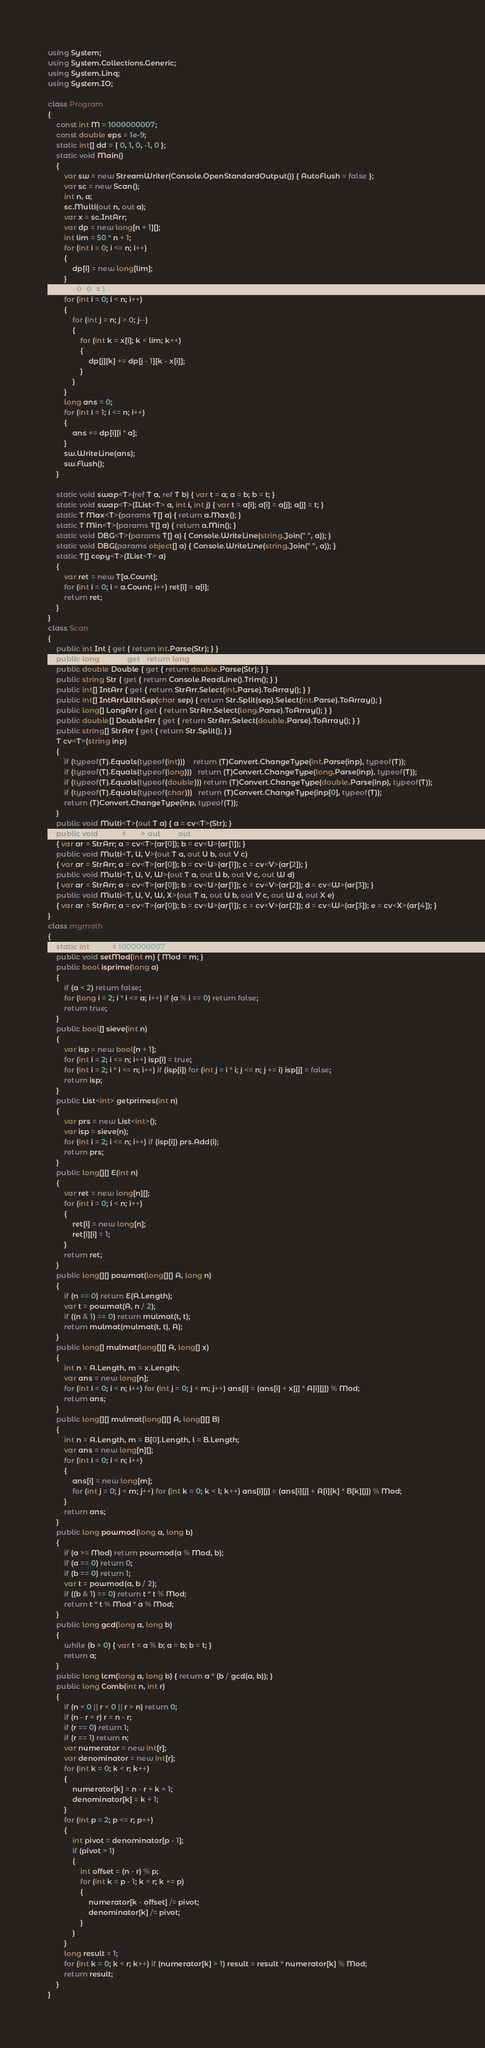Convert code to text. <code><loc_0><loc_0><loc_500><loc_500><_C#_>using System;
using System.Collections.Generic;
using System.Linq;
using System.IO;

class Program
{
    const int M = 1000000007;
    const double eps = 1e-9;
    static int[] dd = { 0, 1, 0, -1, 0 };
    static void Main()
    {
        var sw = new StreamWriter(Console.OpenStandardOutput()) { AutoFlush = false };
        var sc = new Scan();
        int n, a;
        sc.Multi(out n, out a);
        var x = sc.IntArr;
        var dp = new long[n + 1][];
        int lim = 50 * n + 1;
        for (int i = 0; i <= n; i++)
        {
            dp[i] = new long[lim];
        }
        dp[0][0] = 1;
        for (int i = 0; i < n; i++)
        {
            for (int j = n; j > 0; j--)
            {
                for (int k = x[i]; k < lim; k++)
                {
                    dp[j][k] += dp[j - 1][k - x[i]];
                }
            }
        }
        long ans = 0;
        for (int i = 1; i <= n; i++)
        {
            ans += dp[i][i * a];
        }
        sw.WriteLine(ans);
        sw.Flush();
    }

    static void swap<T>(ref T a, ref T b) { var t = a; a = b; b = t; }
    static void swap<T>(IList<T> a, int i, int j) { var t = a[i]; a[i] = a[j]; a[j] = t; }
    static T Max<T>(params T[] a) { return a.Max(); }
    static T Min<T>(params T[] a) { return a.Min(); }
    static void DBG<T>(params T[] a) { Console.WriteLine(string.Join(" ", a)); }
    static void DBG(params object[] a) { Console.WriteLine(string.Join(" ", a)); }
    static T[] copy<T>(IList<T> a)
    {
        var ret = new T[a.Count];
        for (int i = 0; i < a.Count; i++) ret[i] = a[i];
        return ret;
    }
}
class Scan
{
    public int Int { get { return int.Parse(Str); } }
    public long Long { get { return long.Parse(Str); } }
    public double Double { get { return double.Parse(Str); } }
    public string Str { get { return Console.ReadLine().Trim(); } }
    public int[] IntArr { get { return StrArr.Select(int.Parse).ToArray(); } }
    public int[] IntArrWithSep(char sep) { return Str.Split(sep).Select(int.Parse).ToArray(); }
    public long[] LongArr { get { return StrArr.Select(long.Parse).ToArray(); } }
    public double[] DoubleArr { get { return StrArr.Select(double.Parse).ToArray(); } }
    public string[] StrArr { get { return Str.Split(); } }
    T cv<T>(string inp)
    {
        if (typeof(T).Equals(typeof(int)))    return (T)Convert.ChangeType(int.Parse(inp), typeof(T));
        if (typeof(T).Equals(typeof(long)))   return (T)Convert.ChangeType(long.Parse(inp), typeof(T));
        if (typeof(T).Equals(typeof(double))) return (T)Convert.ChangeType(double.Parse(inp), typeof(T));
        if (typeof(T).Equals(typeof(char)))   return (T)Convert.ChangeType(inp[0], typeof(T));
        return (T)Convert.ChangeType(inp, typeof(T));
    }
    public void Multi<T>(out T a) { a = cv<T>(Str); }
    public void Multi<T, U>(out T a, out U b)
    { var ar = StrArr; a = cv<T>(ar[0]); b = cv<U>(ar[1]); }
    public void Multi<T, U, V>(out T a, out U b, out V c)
    { var ar = StrArr; a = cv<T>(ar[0]); b = cv<U>(ar[1]); c = cv<V>(ar[2]); }
    public void Multi<T, U, V, W>(out T a, out U b, out V c, out W d)
    { var ar = StrArr; a = cv<T>(ar[0]); b = cv<U>(ar[1]); c = cv<V>(ar[2]); d = cv<W>(ar[3]); }
    public void Multi<T, U, V, W, X>(out T a, out U b, out V c, out W d, out X e)
    { var ar = StrArr; a = cv<T>(ar[0]); b = cv<U>(ar[1]); c = cv<V>(ar[2]); d = cv<W>(ar[3]); e = cv<X>(ar[4]); }
}
class mymath
{
    static int Mod = 1000000007;
    public void setMod(int m) { Mod = m; }
    public bool isprime(long a)
    {
        if (a < 2) return false;
        for (long i = 2; i * i <= a; i++) if (a % i == 0) return false;
        return true;
    }
    public bool[] sieve(int n)
    {
        var isp = new bool[n + 1];
        for (int i = 2; i <= n; i++) isp[i] = true; 
        for (int i = 2; i * i <= n; i++) if (isp[i]) for (int j = i * i; j <= n; j += i) isp[j] = false;
        return isp;
    }
    public List<int> getprimes(int n)
    {
        var prs = new List<int>();
        var isp = sieve(n);
        for (int i = 2; i <= n; i++) if (isp[i]) prs.Add(i);
        return prs;
    }
    public long[][] E(int n)
    {
        var ret = new long[n][];
        for (int i = 0; i < n; i++)
        {
            ret[i] = new long[n];
            ret[i][i] = 1;
        }
        return ret;
    }
    public long[][] powmat(long[][] A, long n)
    {
        if (n == 0) return E(A.Length);
        var t = powmat(A, n / 2);
        if ((n & 1) == 0) return mulmat(t, t);
        return mulmat(mulmat(t, t), A);
    }
    public long[] mulmat(long[][] A, long[] x)
    {
        int n = A.Length, m = x.Length;
        var ans = new long[n];
        for (int i = 0; i < n; i++) for (int j = 0; j < m; j++) ans[i] = (ans[i] + x[j] * A[i][j]) % Mod;
        return ans;
    }
    public long[][] mulmat(long[][] A, long[][] B)
    {
        int n = A.Length, m = B[0].Length, l = B.Length;
        var ans = new long[n][];
        for (int i = 0; i < n; i++)
        {
            ans[i] = new long[m];
            for (int j = 0; j < m; j++) for (int k = 0; k < l; k++) ans[i][j] = (ans[i][j] + A[i][k] * B[k][j]) % Mod;
        }
        return ans;
    }
    public long powmod(long a, long b)
    {
        if (a >= Mod) return powmod(a % Mod, b);
        if (a == 0) return 0;
        if (b == 0) return 1;
        var t = powmod(a, b / 2);
        if ((b & 1) == 0) return t * t % Mod;
        return t * t % Mod * a % Mod;
    }
    public long gcd(long a, long b)
    {
        while (b > 0) { var t = a % b; a = b; b = t; }
        return a;
    }
    public long lcm(long a, long b) { return a * (b / gcd(a, b)); }
    public long Comb(int n, int r)
    {
        if (n < 0 || r < 0 || r > n) return 0;
        if (n - r < r) r = n - r;
        if (r == 0) return 1;
        if (r == 1) return n;
        var numerator = new int[r];
        var denominator = new int[r];
        for (int k = 0; k < r; k++)
        {
            numerator[k] = n - r + k + 1;
            denominator[k] = k + 1;
        }
        for (int p = 2; p <= r; p++)
        {
            int pivot = denominator[p - 1];
            if (pivot > 1)
            {
                int offset = (n - r) % p;
                for (int k = p - 1; k < r; k += p)
                {
                    numerator[k - offset] /= pivot;
                    denominator[k] /= pivot;
                }
            }
        }
        long result = 1;
        for (int k = 0; k < r; k++) if (numerator[k] > 1) result = result * numerator[k] % Mod;
        return result;
    }
}
</code> 